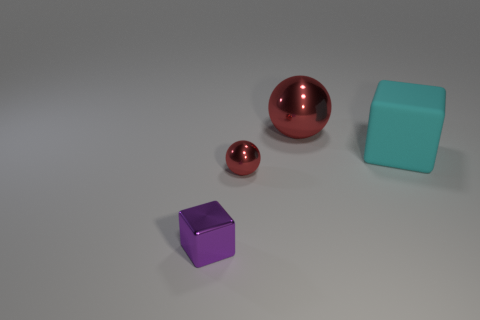Add 4 tiny red objects. How many objects exist? 8 Subtract all tiny yellow metallic blocks. Subtract all shiny cubes. How many objects are left? 3 Add 3 shiny spheres. How many shiny spheres are left? 5 Add 1 cyan metal blocks. How many cyan metal blocks exist? 1 Subtract 0 gray cylinders. How many objects are left? 4 